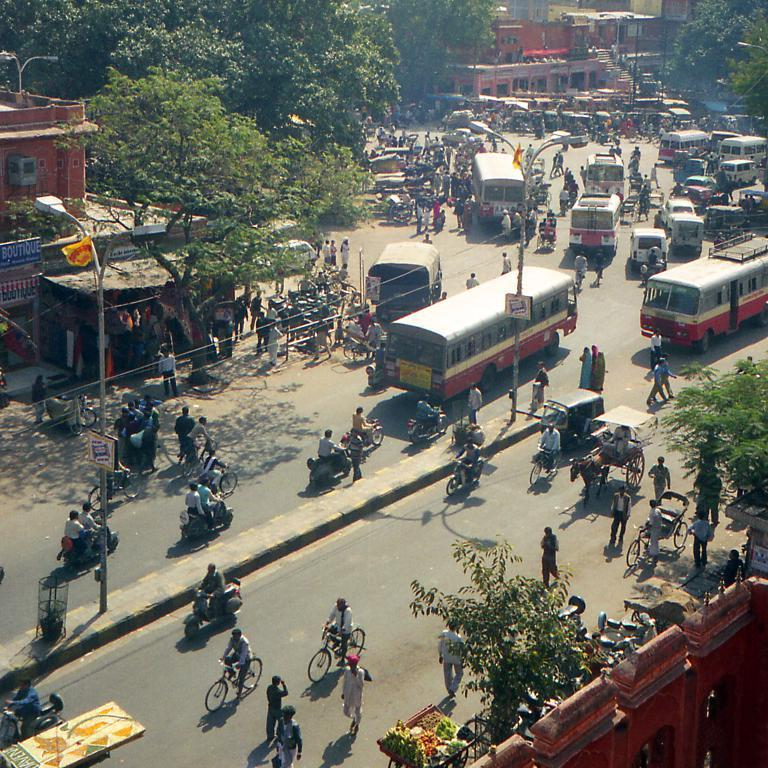<image>
Present a compact description of the photo's key features. A blue sign has the word boutique on it. 